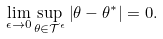Convert formula to latex. <formula><loc_0><loc_0><loc_500><loc_500>\lim _ { \epsilon \to 0 } \sup _ { \theta \in \mathcal { T } ^ { \epsilon } } \left | \theta - \theta ^ { \ast } \right | = 0 .</formula> 